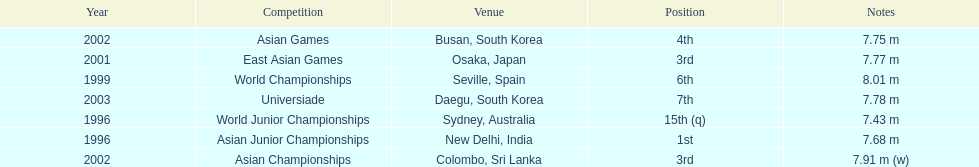How many competitions did he place in the top three? 3. 